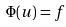<formula> <loc_0><loc_0><loc_500><loc_500>\Phi ( u ) = f</formula> 